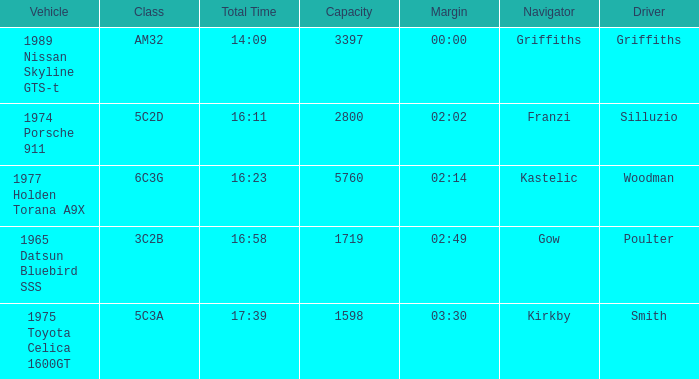What's the lowest capacity when the margin is 03:30? 1598.0. 